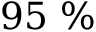Convert formula to latex. <formula><loc_0><loc_0><loc_500><loc_500>9 5 \ \%</formula> 